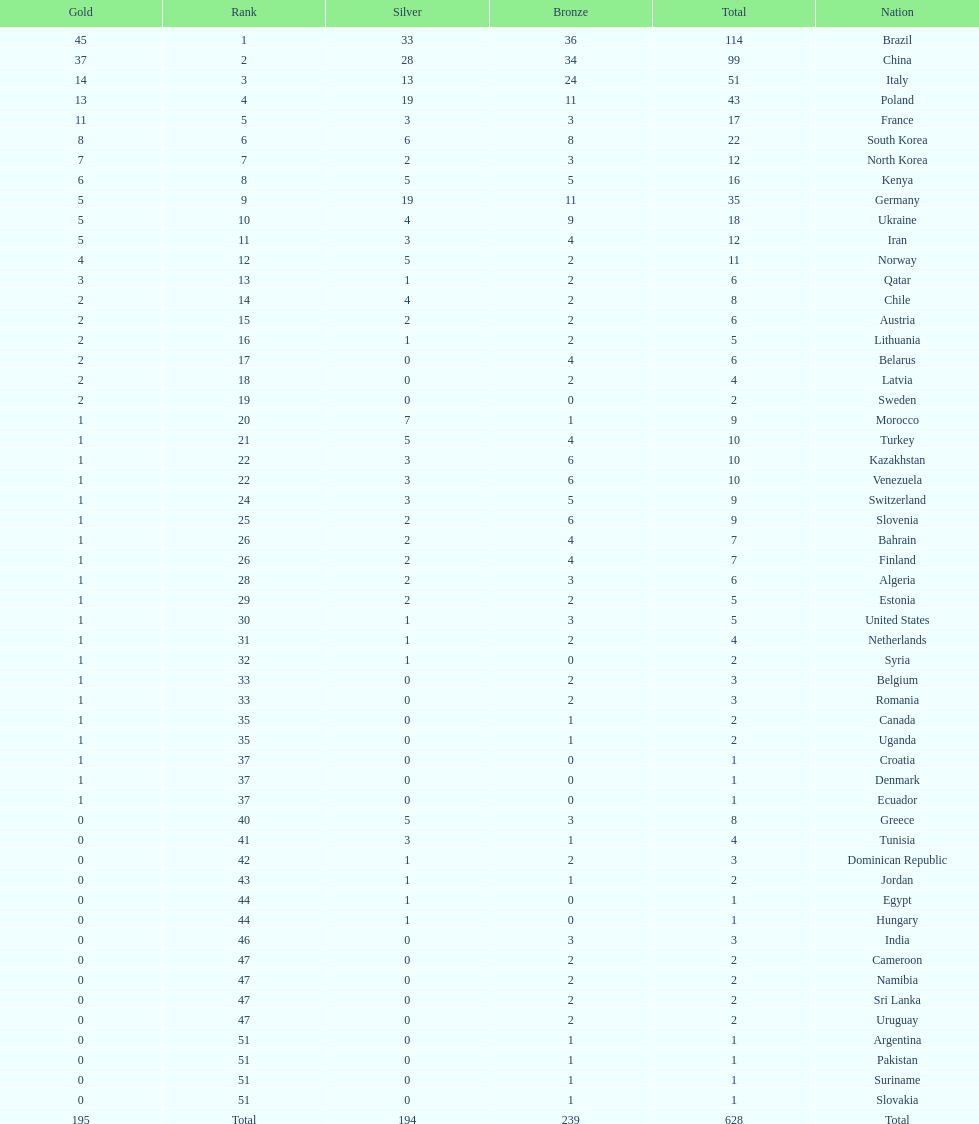Which type of medal does belarus not have? Silver. 